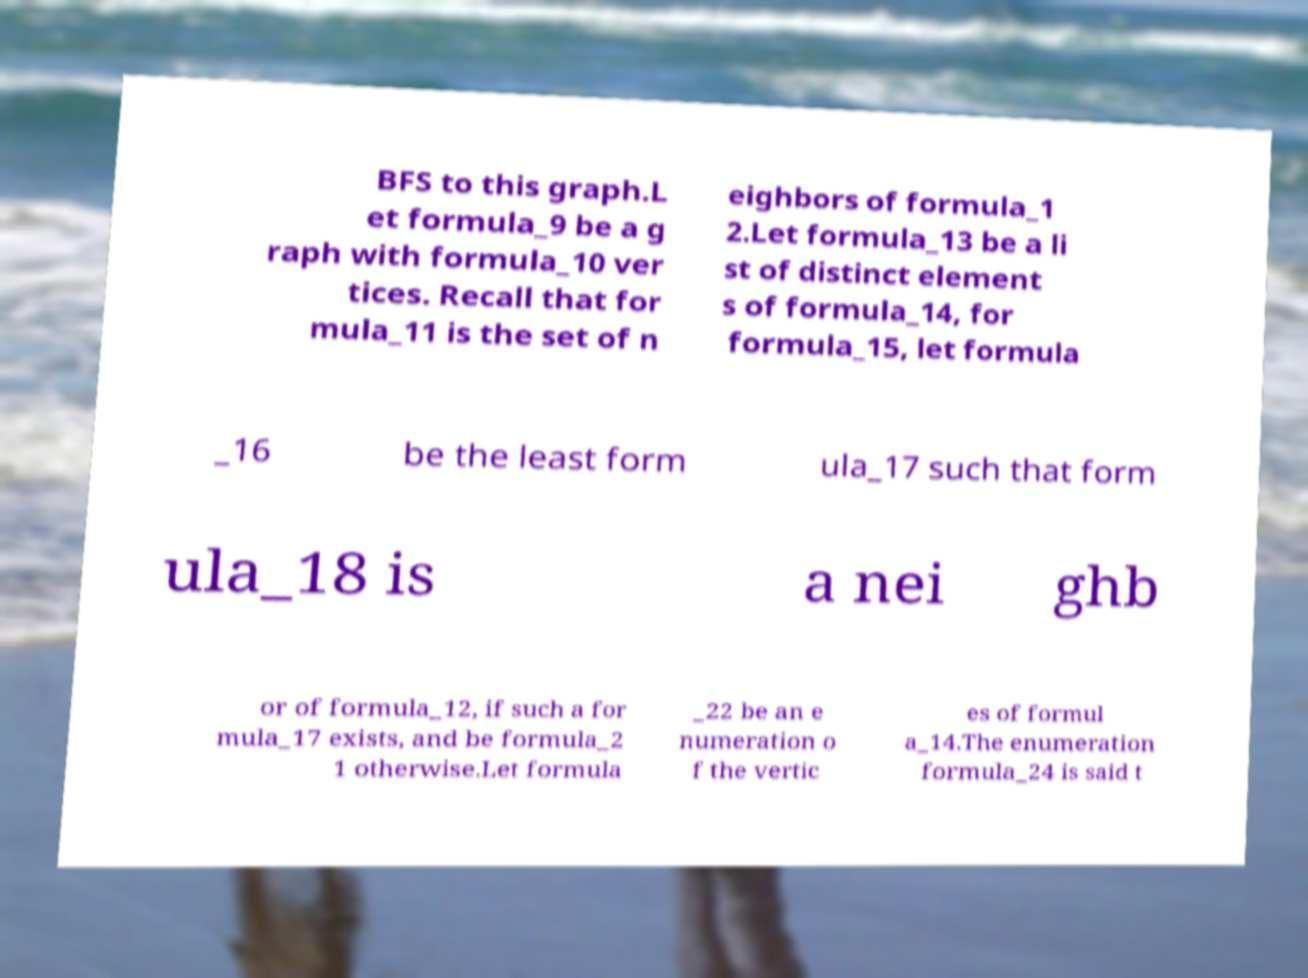Please identify and transcribe the text found in this image. BFS to this graph.L et formula_9 be a g raph with formula_10 ver tices. Recall that for mula_11 is the set of n eighbors of formula_1 2.Let formula_13 be a li st of distinct element s of formula_14, for formula_15, let formula _16 be the least form ula_17 such that form ula_18 is a nei ghb or of formula_12, if such a for mula_17 exists, and be formula_2 1 otherwise.Let formula _22 be an e numeration o f the vertic es of formul a_14.The enumeration formula_24 is said t 